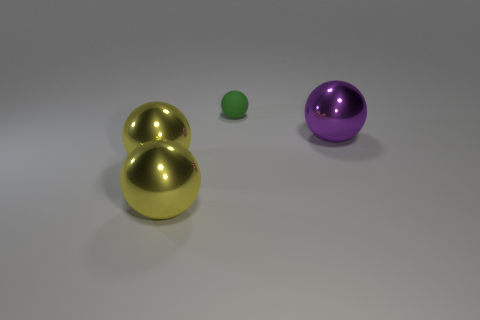Add 1 tiny rubber spheres. How many objects exist? 5 Subtract 0 cyan blocks. How many objects are left? 4 Subtract all green spheres. Subtract all small green cylinders. How many objects are left? 3 Add 4 big purple metal spheres. How many big purple metal spheres are left? 5 Add 3 yellow shiny balls. How many yellow shiny balls exist? 5 